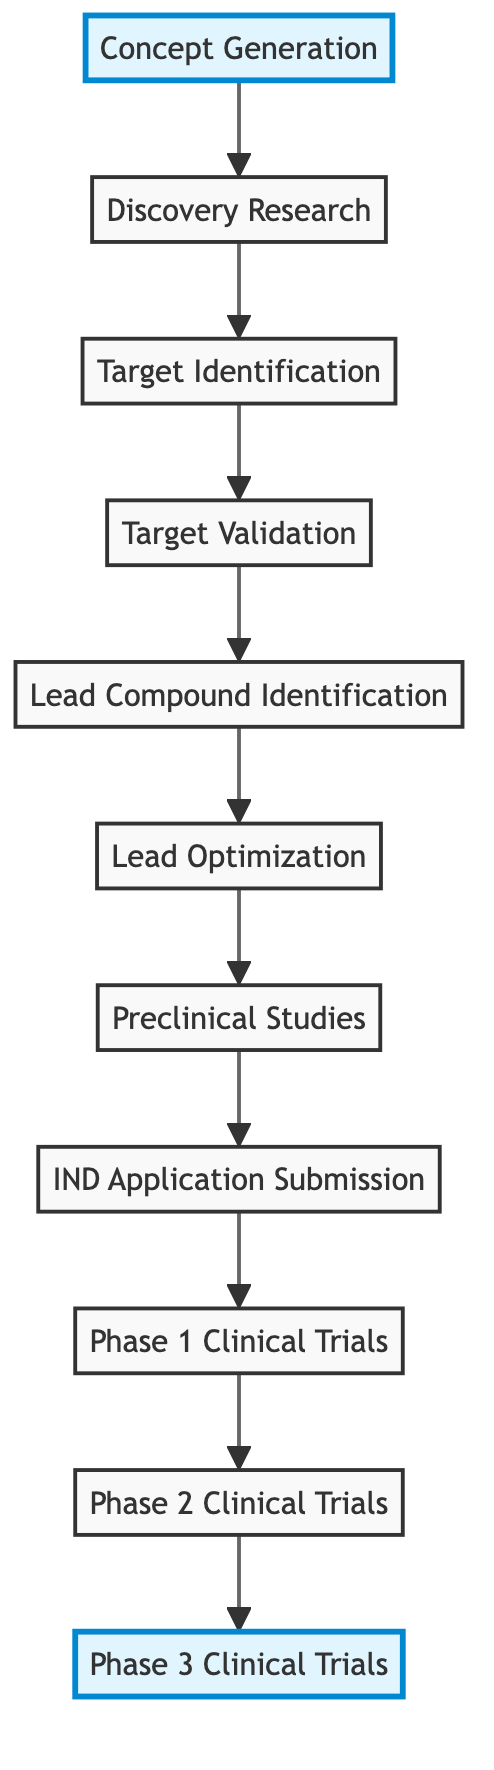What is the starting point of the drug development process represented in the diagram? The diagram indicates that the starting point is "Concept Generation," which is the first element at the bottom of the flowchart.
Answer: Concept Generation What is the last phase before moving on to clinical trials according to the flowchart? The diagram shows that "IND Application Submission" is the stage before clinical trials, positioned just before the Phase 1 Clinical Trials.
Answer: IND Application Submission How many phases of clinical trials are included in the process represented? There are three distinct phases labeled as Phase 1, Phase 2, and Phase 3 Clinical Trials, as indicated at the top of the flowchart.
Answer: Three Which process occurs directly after Lead Optimization? According to the flowchart, "Preclinical Studies" directly follows "Lead Optimization," indicating the order of processes during drug development.
Answer: Preclinical Studies What is the relationship between Target Validation and Lead Compound Identification? The diagram shows that "Target Validation" occurs before "Lead Compound Identification," implying that validating the biological target is necessary before choosing the lead compounds.
Answer: Target Validation precedes Lead Compound Identification Which term in the flowchart signifies the stage where compounds are tested for safety? "Phase 1 Clinical Trials" is indicated in the flowchart as the stage specifically focused on assessing the safety, dosage, and side effects of lead compounds.
Answer: Phase 1 Clinical Trials What type of research is indicated at the beginning of the drug development process? The flowchart identifies "Discovery Research" as the initial type of research aimed at understanding disease mechanisms and potential drug intervention points.
Answer: Discovery Research How does "Lead Optimization" contribute to the drug development process? "Lead Optimization" is aimed at refining lead compounds for improved efficacy and reduced toxicity, making it a crucial step in preparing for preclinical studies.
Answer: Refines compounds for efficacy and toxicity In what contexts might "Target Identification" primarily be used as shown in the flowchart? The flowchart illustrates that "Target Identification" is centered around biological research studies, highlighting its role in discovering relevant biological targets related to diseases.
Answer: Biological research studies 